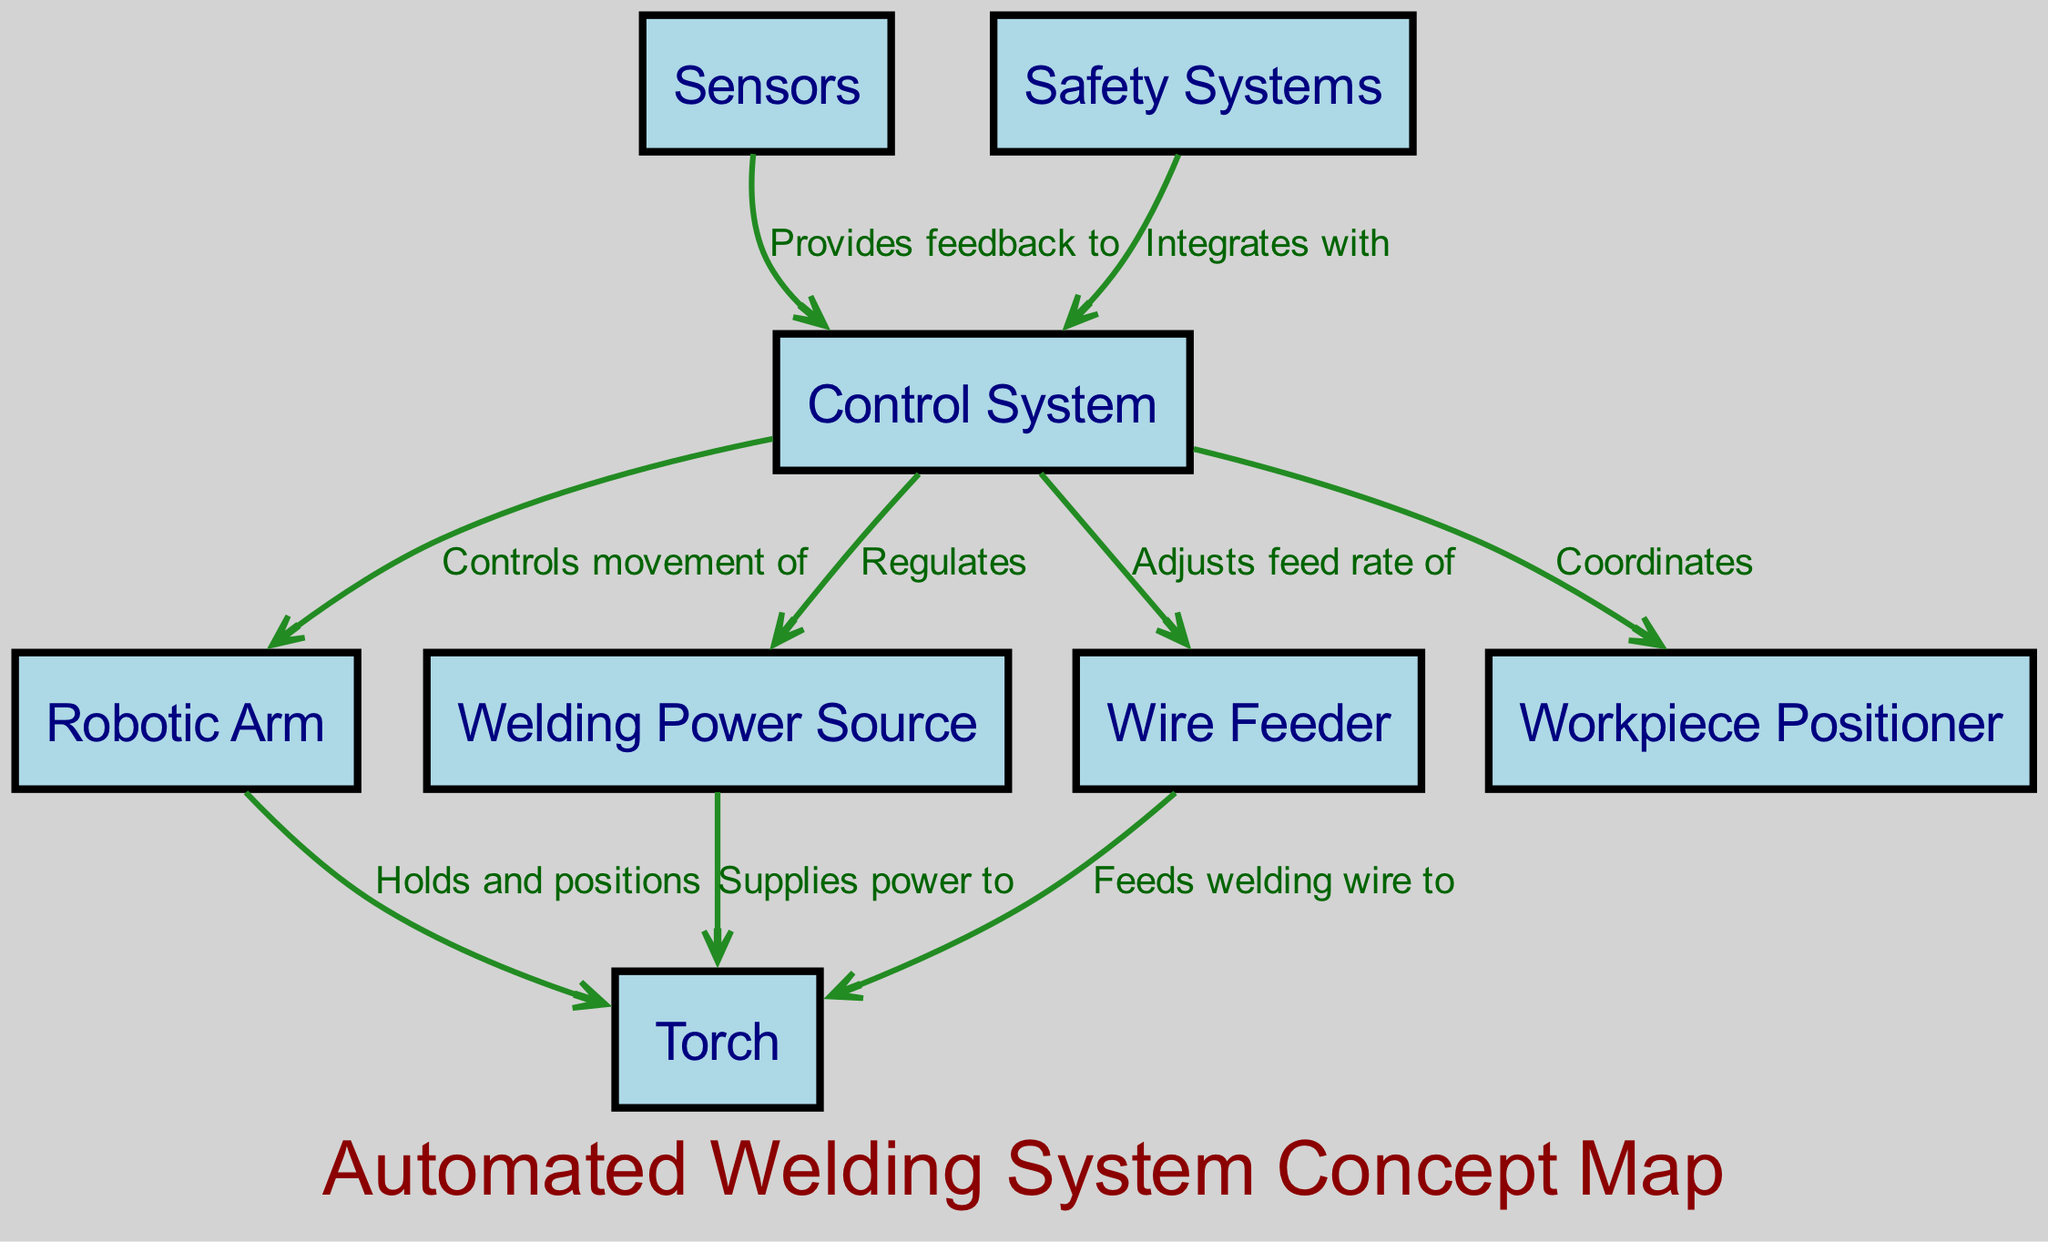What is the total number of nodes in the diagram? The diagram contains a specific number of nodes, which can be counted directly from the nodes list. The nodes present are: Robotic Arm, Welding Power Source, Wire Feeder, Torch, Control System, Workpiece Positioner, Sensors, and Safety Systems. Counting these gives a total of eight nodes.
Answer: 8 What role does the Control System play in relation to the Robotic Arm? The Control System is shown to have a direct relationship with the Robotic Arm, specifically controlling its movement. This connection can be traced by following the edge labeled "Controls movement of" from the Control System to the Robotic Arm.
Answer: Controls movement of Which component supplies power to the Torch? The edge labeled "Supplies power to" leads from the Welding Power Source to the Torch. Following this edge reveals that the Welding Power Source is responsible for providing power specifically to the Torch in the system.
Answer: Welding Power Source How many interactions involve the Control System? To find the number of interactions involving the Control System, I look at how many edges connect to or originate from it. The Control System has four edges: it controls the Robotic Arm, regulates the Welding Power Source, adjusts the feed rate of the Wire Feeder, and coordinates with the Workpiece Positioner. Therefore, it is involved in four interactions.
Answer: 4 What does the Safety Systems component integrate with? The diagram clearly indicates that the Safety Systems integrate with the Control System through the edge labeled "Integrates with." This connection emphasizes the relationship that Safety Systems have to the Control System in the automated welding setup.
Answer: Control System Which component feeds welding wire to the Torch? The Wire Feeder is indicated in the diagram to have a direct feeding relationship to the Torch. This is confirmed by the edge labeled "Feeds welding wire to" that connects the Wire Feeder to the Torch, demonstrating this specific function.
Answer: Wire Feeder What is the main function of the Sensors within the system? The Sensors provide feedback to the Control System, as shown by the edge that connects these two components with the label "Provides feedback to." This relationship highlights the Sensors' critical role in communicating data back to the Control System.
Answer: Provides feedback to What connects the Workpiece Positioner and the Control System? The Workpiece Positioner is connected to the Control System, and the relationship is defined as "Coordinates." This shows how the Control System manages and coordinates the movements or positioning of the Workpiece Positioner in the welding operation.
Answer: Coordinates 